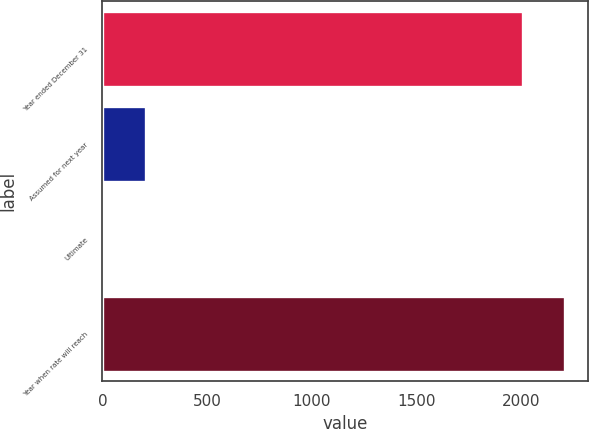Convert chart. <chart><loc_0><loc_0><loc_500><loc_500><bar_chart><fcel>Year ended December 31<fcel>Assumed for next year<fcel>Ultimate<fcel>Year when rate will reach<nl><fcel>2006<fcel>205.8<fcel>5<fcel>2206.8<nl></chart> 